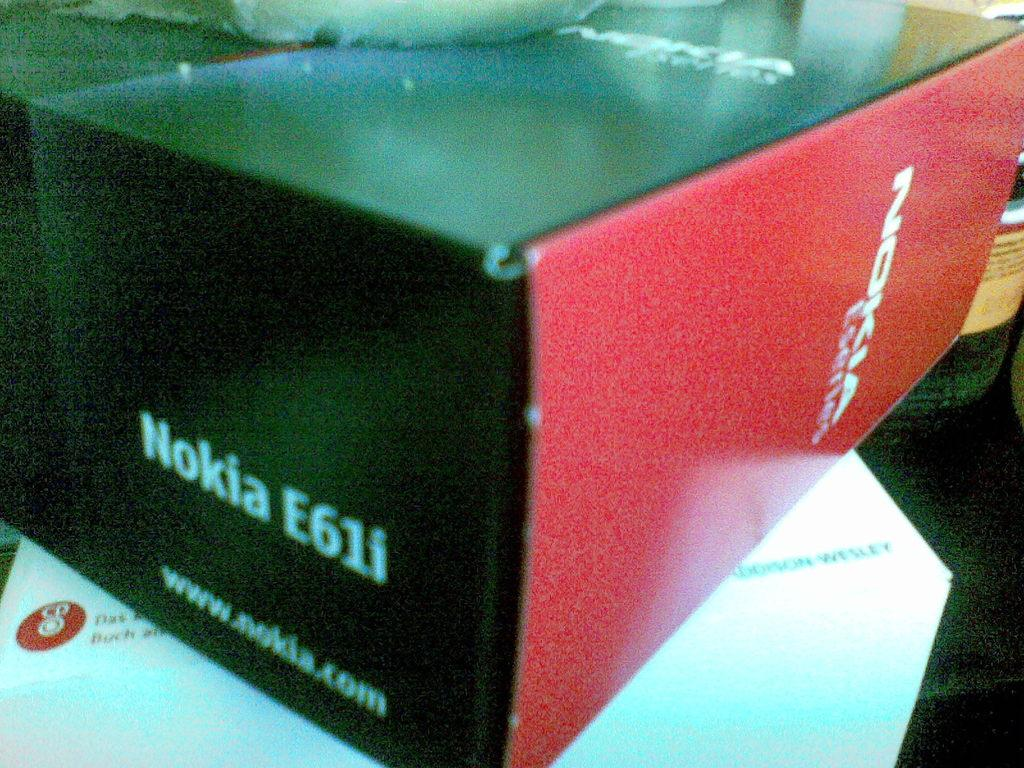<image>
Relay a brief, clear account of the picture shown. A product box contains something manufactured by the Nokia company. 